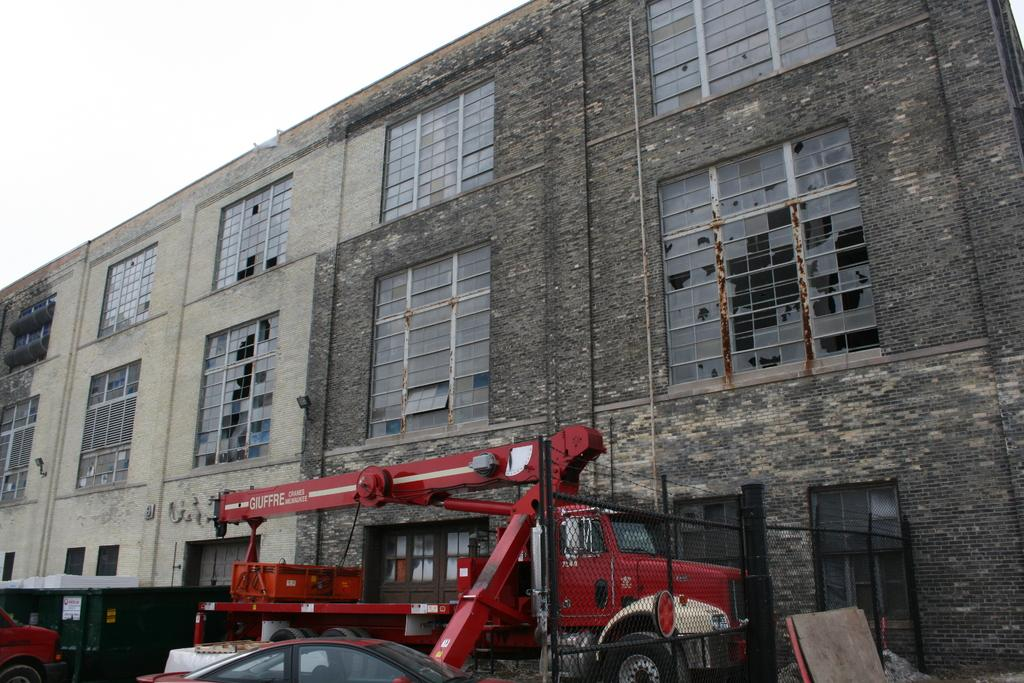What types of vehicles can be seen in the image? There are vehicles in the image, but the specific types are not mentioned. What is the large machine with a long arm in the image? There is a crane in the image. What structure is visible in the image? There is a building in the image. What part of the building can be seen in the image? There are windows in the image. What can be seen in the background of the image? The sky is visible in the background of the image. Can you tell me how many toads are sitting on the crane in the image? There are no toads present in the image; it features vehicles, a crane, a building, windows, and the sky. What is the user's mind doing in the image? The user's mind is not visible in the image, as it is an abstract concept and not a physical object. 